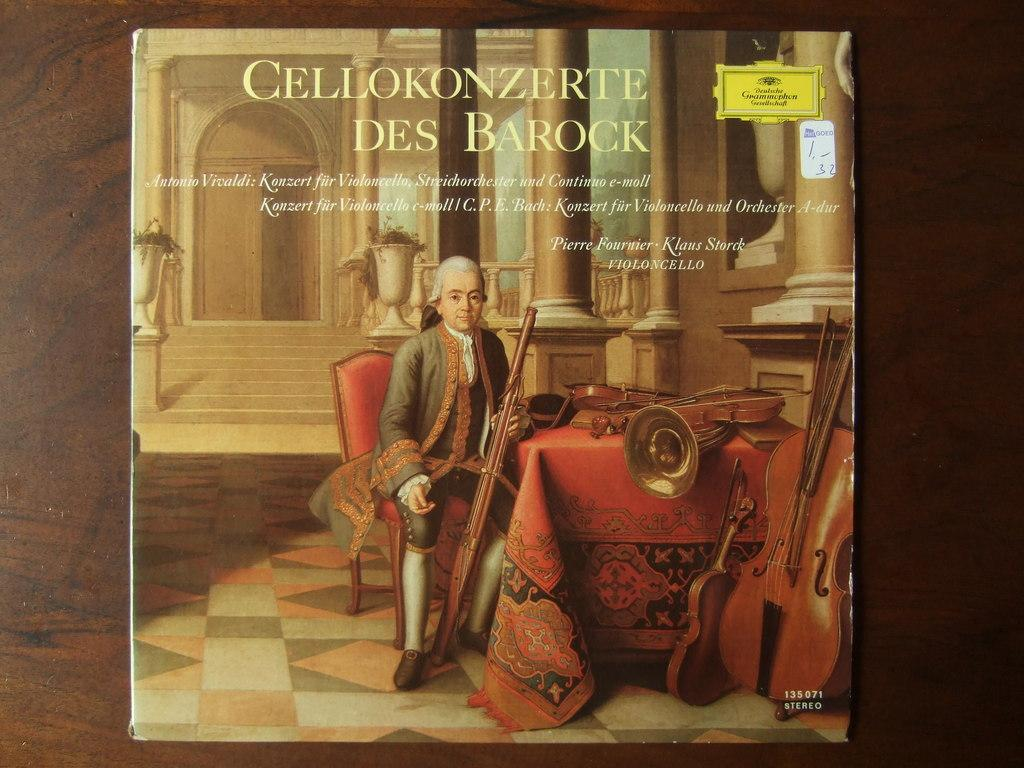<image>
Offer a succinct explanation of the picture presented. Cellokonzerte Des Barock album cover featuring a gentleman sitting next to various instruments. 